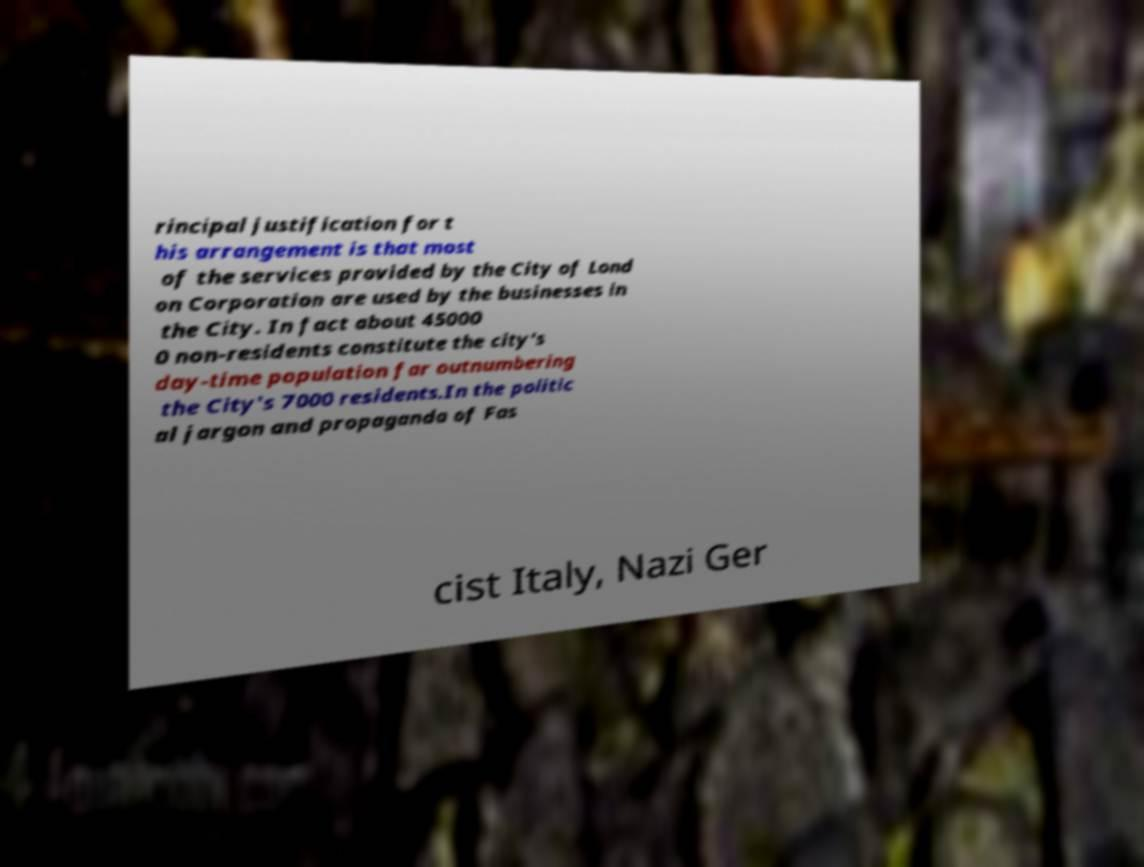Could you extract and type out the text from this image? rincipal justification for t his arrangement is that most of the services provided by the City of Lond on Corporation are used by the businesses in the City. In fact about 45000 0 non-residents constitute the city's day-time population far outnumbering the City's 7000 residents.In the politic al jargon and propaganda of Fas cist Italy, Nazi Ger 